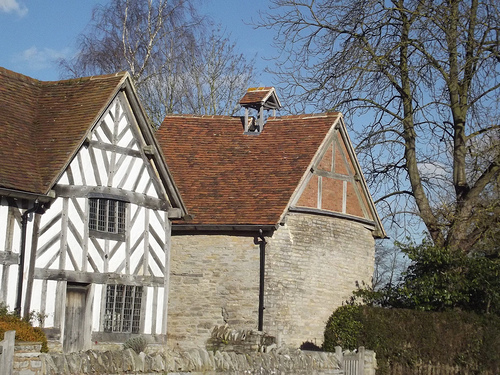<image>
Can you confirm if the house is behind the house? No. The house is not behind the house. From this viewpoint, the house appears to be positioned elsewhere in the scene. 